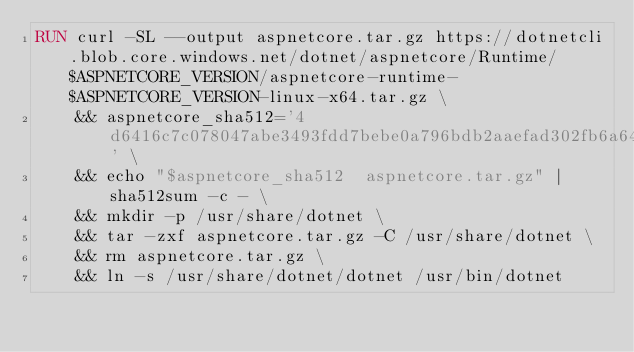<code> <loc_0><loc_0><loc_500><loc_500><_Dockerfile_>RUN curl -SL --output aspnetcore.tar.gz https://dotnetcli.blob.core.windows.net/dotnet/aspnetcore/Runtime/$ASPNETCORE_VERSION/aspnetcore-runtime-$ASPNETCORE_VERSION-linux-x64.tar.gz \
    && aspnetcore_sha512='4d6416c7c078047abe3493fdd7bebe0a796bdb2aaefad302fb6a64dd225c871a1183f016f0974c6dcd82f80ae893660b2aeac2abb70509435845a430e0117e29' \
    && echo "$aspnetcore_sha512  aspnetcore.tar.gz" | sha512sum -c - \
    && mkdir -p /usr/share/dotnet \
    && tar -zxf aspnetcore.tar.gz -C /usr/share/dotnet \
    && rm aspnetcore.tar.gz \
    && ln -s /usr/share/dotnet/dotnet /usr/bin/dotnet
</code> 